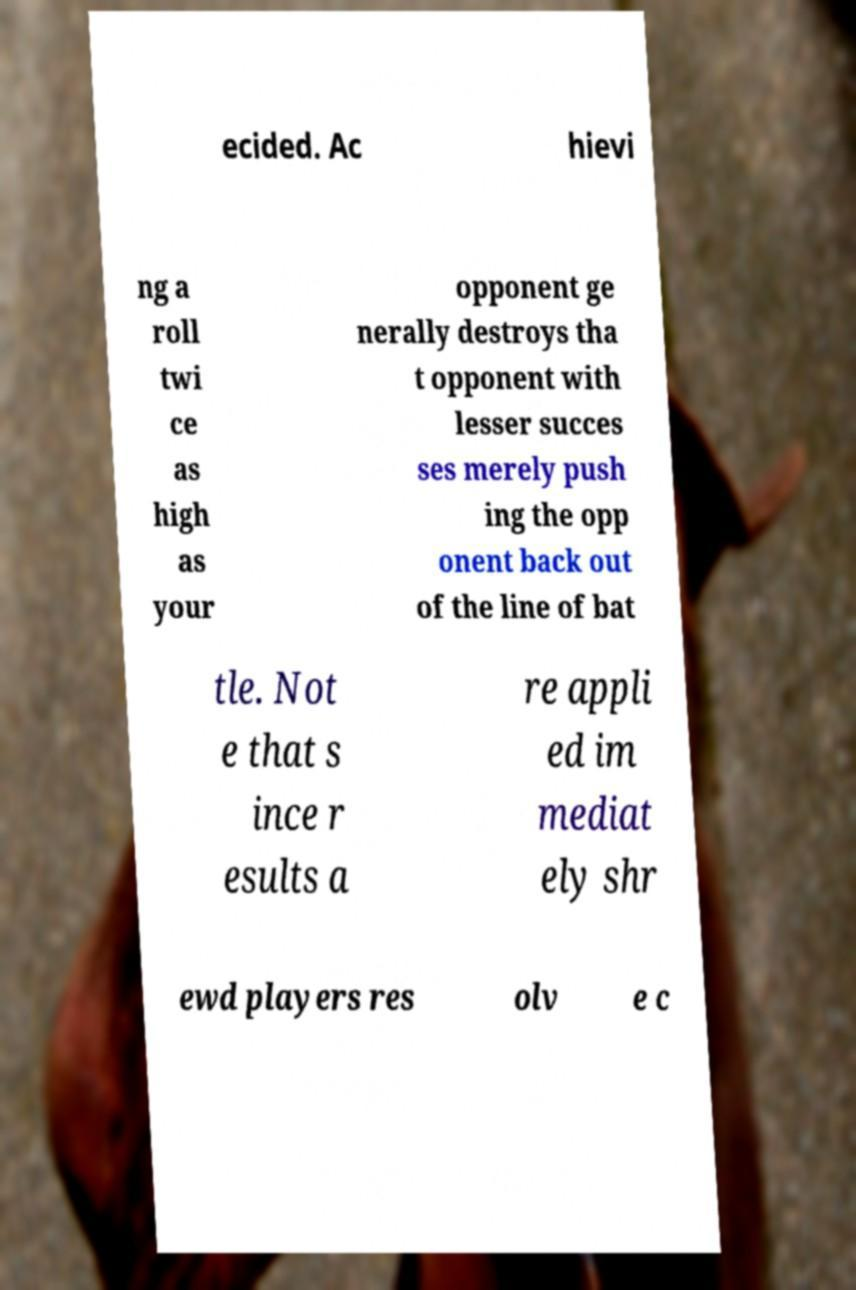For documentation purposes, I need the text within this image transcribed. Could you provide that? ecided. Ac hievi ng a roll twi ce as high as your opponent ge nerally destroys tha t opponent with lesser succes ses merely push ing the opp onent back out of the line of bat tle. Not e that s ince r esults a re appli ed im mediat ely shr ewd players res olv e c 